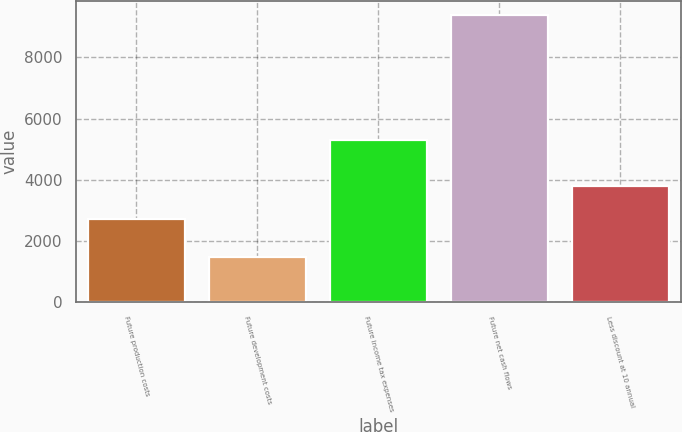Convert chart. <chart><loc_0><loc_0><loc_500><loc_500><bar_chart><fcel>Future production costs<fcel>Future development costs<fcel>Future income tax expenses<fcel>Future net cash flows<fcel>Less discount at 10 annual<nl><fcel>2733<fcel>1472<fcel>5291<fcel>9380<fcel>3792<nl></chart> 